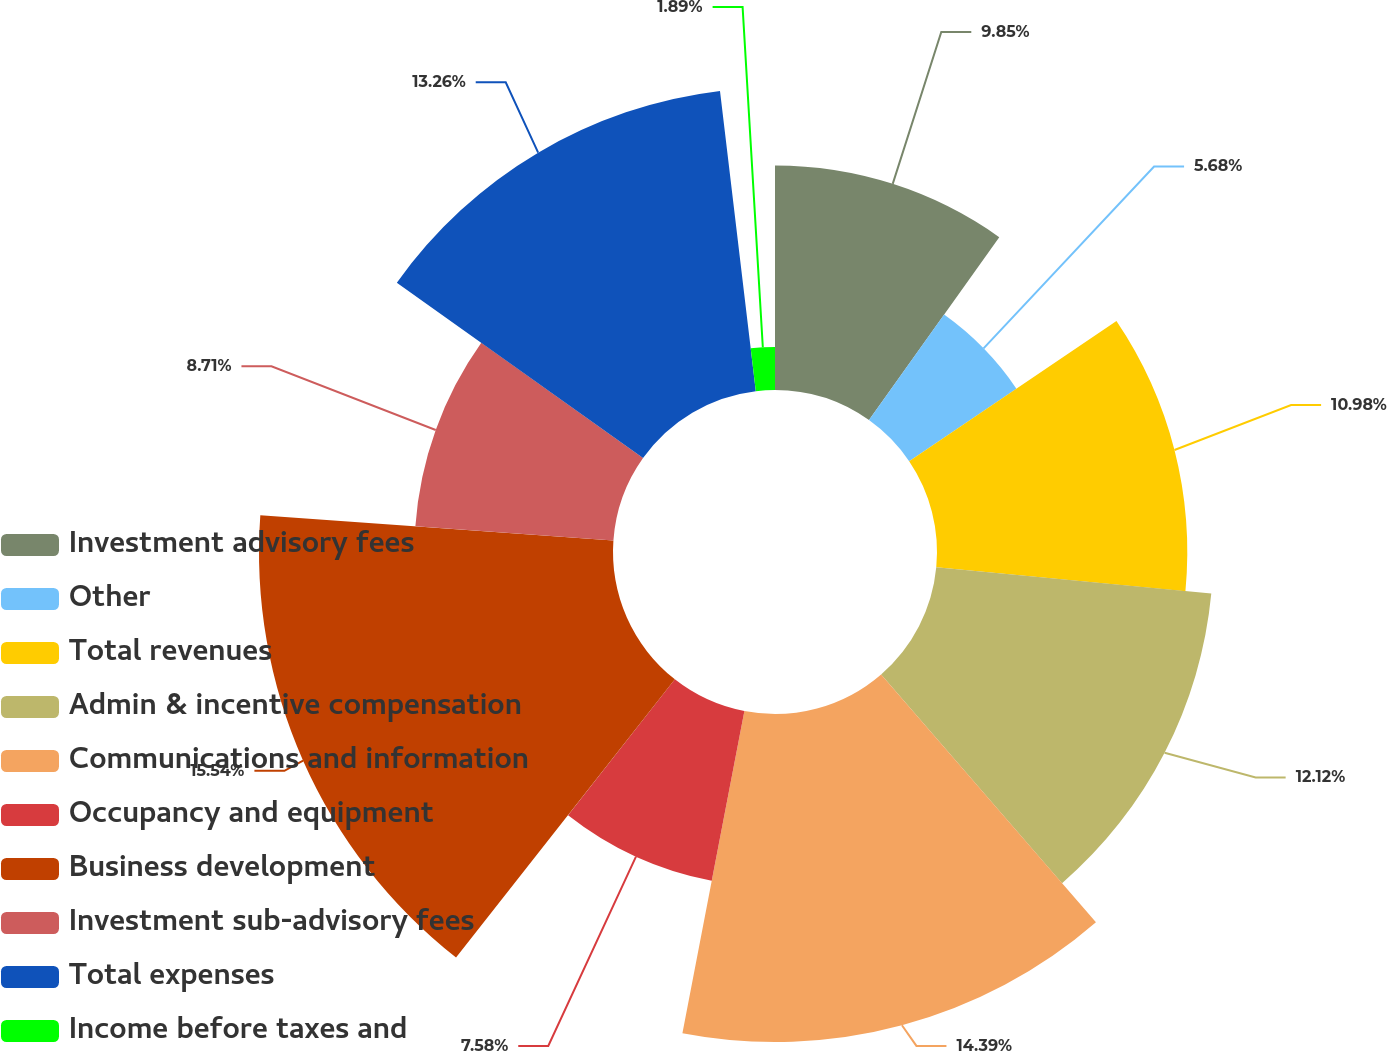Convert chart to OTSL. <chart><loc_0><loc_0><loc_500><loc_500><pie_chart><fcel>Investment advisory fees<fcel>Other<fcel>Total revenues<fcel>Admin & incentive compensation<fcel>Communications and information<fcel>Occupancy and equipment<fcel>Business development<fcel>Investment sub-advisory fees<fcel>Total expenses<fcel>Income before taxes and<nl><fcel>9.85%<fcel>5.68%<fcel>10.98%<fcel>12.12%<fcel>14.39%<fcel>7.58%<fcel>15.53%<fcel>8.71%<fcel>13.26%<fcel>1.89%<nl></chart> 